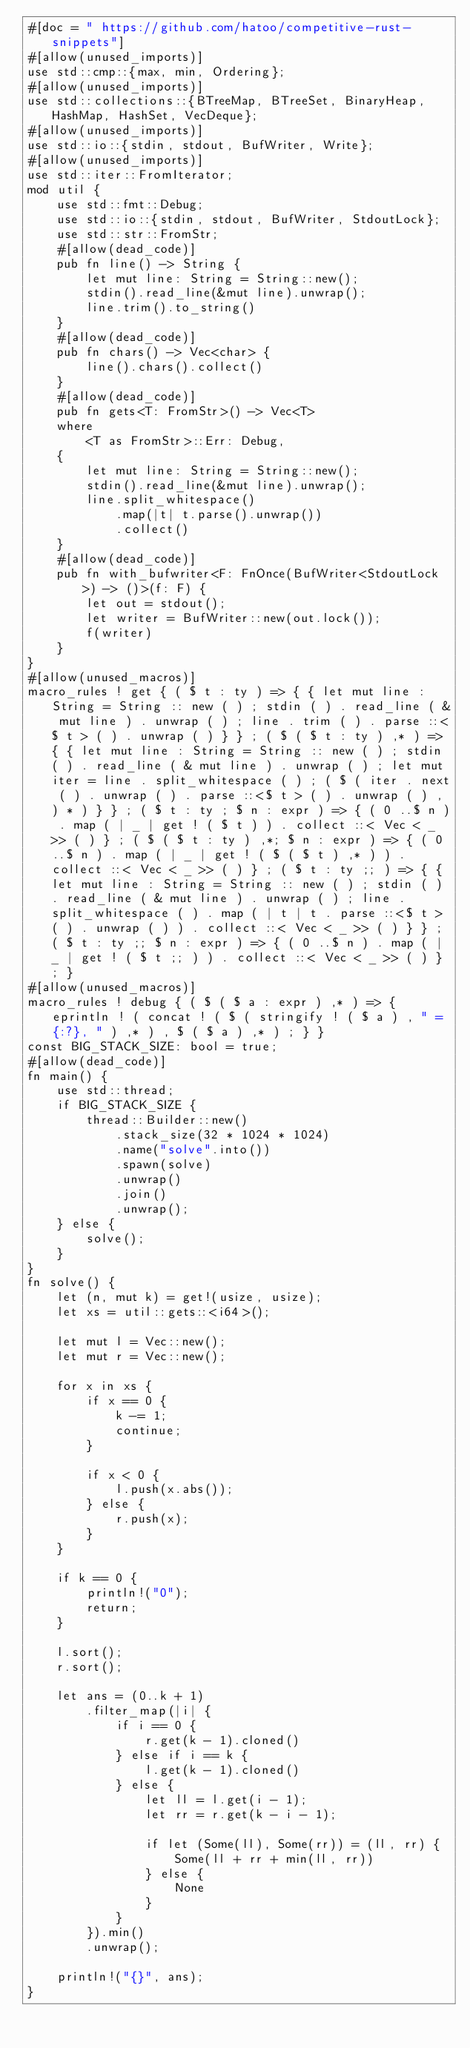<code> <loc_0><loc_0><loc_500><loc_500><_Rust_>#[doc = " https://github.com/hatoo/competitive-rust-snippets"]
#[allow(unused_imports)]
use std::cmp::{max, min, Ordering};
#[allow(unused_imports)]
use std::collections::{BTreeMap, BTreeSet, BinaryHeap, HashMap, HashSet, VecDeque};
#[allow(unused_imports)]
use std::io::{stdin, stdout, BufWriter, Write};
#[allow(unused_imports)]
use std::iter::FromIterator;
mod util {
    use std::fmt::Debug;
    use std::io::{stdin, stdout, BufWriter, StdoutLock};
    use std::str::FromStr;
    #[allow(dead_code)]
    pub fn line() -> String {
        let mut line: String = String::new();
        stdin().read_line(&mut line).unwrap();
        line.trim().to_string()
    }
    #[allow(dead_code)]
    pub fn chars() -> Vec<char> {
        line().chars().collect()
    }
    #[allow(dead_code)]
    pub fn gets<T: FromStr>() -> Vec<T>
    where
        <T as FromStr>::Err: Debug,
    {
        let mut line: String = String::new();
        stdin().read_line(&mut line).unwrap();
        line.split_whitespace()
            .map(|t| t.parse().unwrap())
            .collect()
    }
    #[allow(dead_code)]
    pub fn with_bufwriter<F: FnOnce(BufWriter<StdoutLock>) -> ()>(f: F) {
        let out = stdout();
        let writer = BufWriter::new(out.lock());
        f(writer)
    }
}
#[allow(unused_macros)]
macro_rules ! get { ( $ t : ty ) => { { let mut line : String = String :: new ( ) ; stdin ( ) . read_line ( & mut line ) . unwrap ( ) ; line . trim ( ) . parse ::<$ t > ( ) . unwrap ( ) } } ; ( $ ( $ t : ty ) ,* ) => { { let mut line : String = String :: new ( ) ; stdin ( ) . read_line ( & mut line ) . unwrap ( ) ; let mut iter = line . split_whitespace ( ) ; ( $ ( iter . next ( ) . unwrap ( ) . parse ::<$ t > ( ) . unwrap ( ) , ) * ) } } ; ( $ t : ty ; $ n : expr ) => { ( 0 ..$ n ) . map ( | _ | get ! ( $ t ) ) . collect ::< Vec < _ >> ( ) } ; ( $ ( $ t : ty ) ,*; $ n : expr ) => { ( 0 ..$ n ) . map ( | _ | get ! ( $ ( $ t ) ,* ) ) . collect ::< Vec < _ >> ( ) } ; ( $ t : ty ;; ) => { { let mut line : String = String :: new ( ) ; stdin ( ) . read_line ( & mut line ) . unwrap ( ) ; line . split_whitespace ( ) . map ( | t | t . parse ::<$ t > ( ) . unwrap ( ) ) . collect ::< Vec < _ >> ( ) } } ; ( $ t : ty ;; $ n : expr ) => { ( 0 ..$ n ) . map ( | _ | get ! ( $ t ;; ) ) . collect ::< Vec < _ >> ( ) } ; }
#[allow(unused_macros)]
macro_rules ! debug { ( $ ( $ a : expr ) ,* ) => { eprintln ! ( concat ! ( $ ( stringify ! ( $ a ) , " = {:?}, " ) ,* ) , $ ( $ a ) ,* ) ; } }
const BIG_STACK_SIZE: bool = true;
#[allow(dead_code)]
fn main() {
    use std::thread;
    if BIG_STACK_SIZE {
        thread::Builder::new()
            .stack_size(32 * 1024 * 1024)
            .name("solve".into())
            .spawn(solve)
            .unwrap()
            .join()
            .unwrap();
    } else {
        solve();
    }
}
fn solve() {
    let (n, mut k) = get!(usize, usize);
    let xs = util::gets::<i64>();

    let mut l = Vec::new();
    let mut r = Vec::new();

    for x in xs {
        if x == 0 {
            k -= 1;
            continue;
        }

        if x < 0 {
            l.push(x.abs());
        } else {
            r.push(x);
        }
    }

    if k == 0 {
        println!("0");
        return;
    }

    l.sort();
    r.sort();

    let ans = (0..k + 1)
        .filter_map(|i| {
            if i == 0 {
                r.get(k - 1).cloned()
            } else if i == k {
                l.get(k - 1).cloned()
            } else {
                let ll = l.get(i - 1);
                let rr = r.get(k - i - 1);

                if let (Some(ll), Some(rr)) = (ll, rr) {
                    Some(ll + rr + min(ll, rr))
                } else {
                    None
                }
            }
        }).min()
        .unwrap();

    println!("{}", ans);
}
</code> 